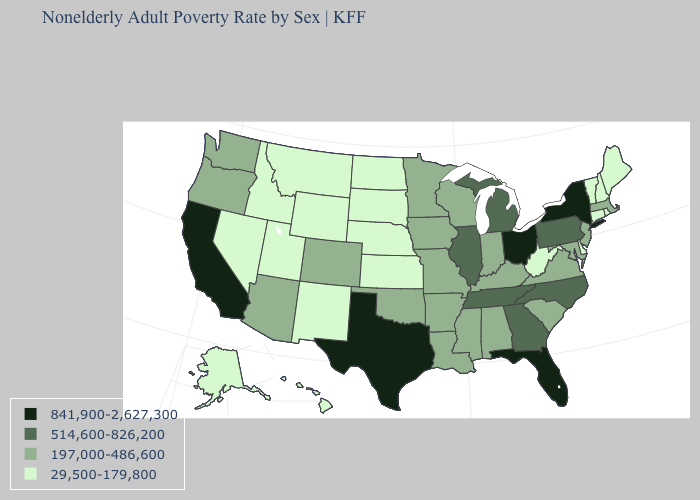Name the states that have a value in the range 29,500-179,800?
Write a very short answer. Alaska, Connecticut, Delaware, Hawaii, Idaho, Kansas, Maine, Montana, Nebraska, Nevada, New Hampshire, New Mexico, North Dakota, Rhode Island, South Dakota, Utah, Vermont, West Virginia, Wyoming. What is the highest value in the West ?
Answer briefly. 841,900-2,627,300. What is the value of Oregon?
Concise answer only. 197,000-486,600. What is the highest value in the West ?
Quick response, please. 841,900-2,627,300. Name the states that have a value in the range 197,000-486,600?
Give a very brief answer. Alabama, Arizona, Arkansas, Colorado, Indiana, Iowa, Kentucky, Louisiana, Maryland, Massachusetts, Minnesota, Mississippi, Missouri, New Jersey, Oklahoma, Oregon, South Carolina, Virginia, Washington, Wisconsin. Name the states that have a value in the range 514,600-826,200?
Concise answer only. Georgia, Illinois, Michigan, North Carolina, Pennsylvania, Tennessee. Which states have the lowest value in the USA?
Be succinct. Alaska, Connecticut, Delaware, Hawaii, Idaho, Kansas, Maine, Montana, Nebraska, Nevada, New Hampshire, New Mexico, North Dakota, Rhode Island, South Dakota, Utah, Vermont, West Virginia, Wyoming. What is the highest value in states that border Vermont?
Concise answer only. 841,900-2,627,300. Does Illinois have the lowest value in the MidWest?
Give a very brief answer. No. What is the value of Oregon?
Answer briefly. 197,000-486,600. Among the states that border Vermont , which have the highest value?
Be succinct. New York. What is the value of West Virginia?
Quick response, please. 29,500-179,800. Which states have the lowest value in the USA?
Write a very short answer. Alaska, Connecticut, Delaware, Hawaii, Idaho, Kansas, Maine, Montana, Nebraska, Nevada, New Hampshire, New Mexico, North Dakota, Rhode Island, South Dakota, Utah, Vermont, West Virginia, Wyoming. Does North Dakota have the lowest value in the MidWest?
Quick response, please. Yes. Does Rhode Island have a higher value than Missouri?
Keep it brief. No. 